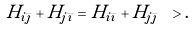<formula> <loc_0><loc_0><loc_500><loc_500>H _ { i \bar { \jmath } } + H _ { j \bar { \imath } } = H _ { i \bar { \imath } } + H _ { j \bar { \jmath } } \ > .</formula> 